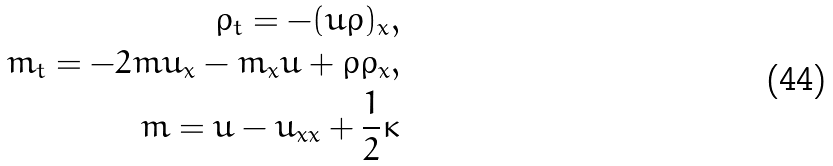Convert formula to latex. <formula><loc_0><loc_0><loc_500><loc_500>\rho _ { t } = - ( u \rho ) _ { x } , \\ m _ { t } = - 2 m u _ { x } - m _ { x } u + \rho \rho _ { x } , \\ m = u - u _ { x x } + \frac { 1 } { 2 } \kappa</formula> 